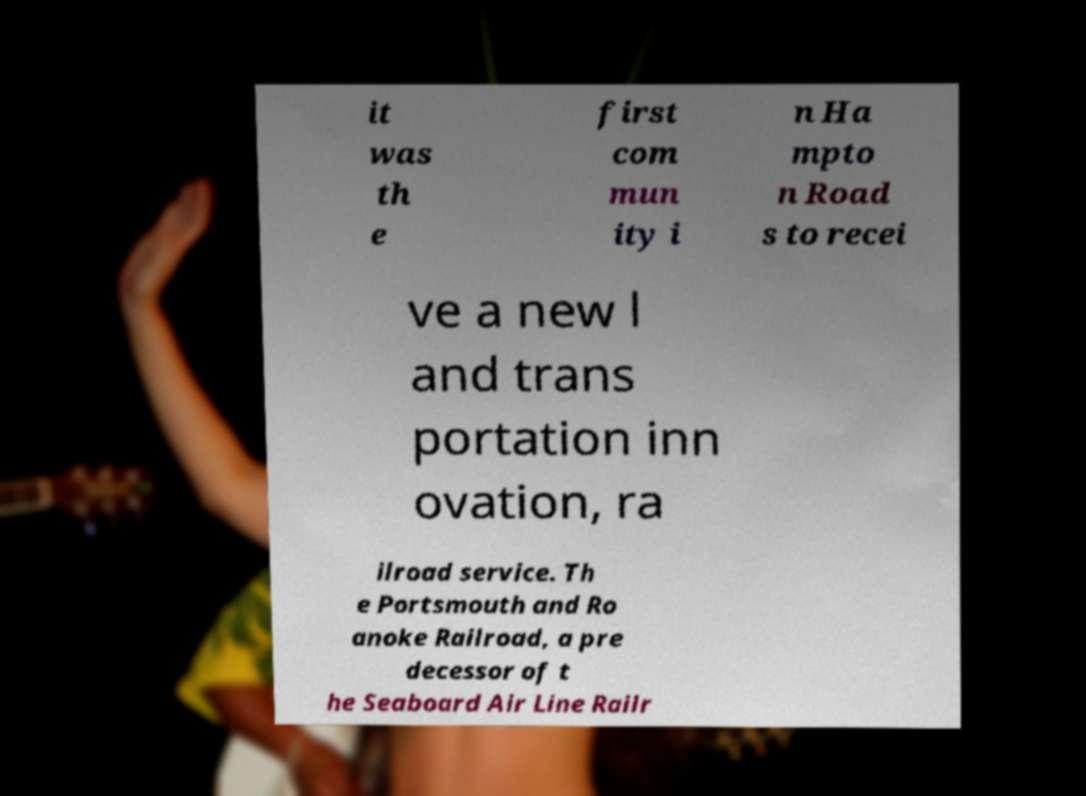There's text embedded in this image that I need extracted. Can you transcribe it verbatim? it was th e first com mun ity i n Ha mpto n Road s to recei ve a new l and trans portation inn ovation, ra ilroad service. Th e Portsmouth and Ro anoke Railroad, a pre decessor of t he Seaboard Air Line Railr 